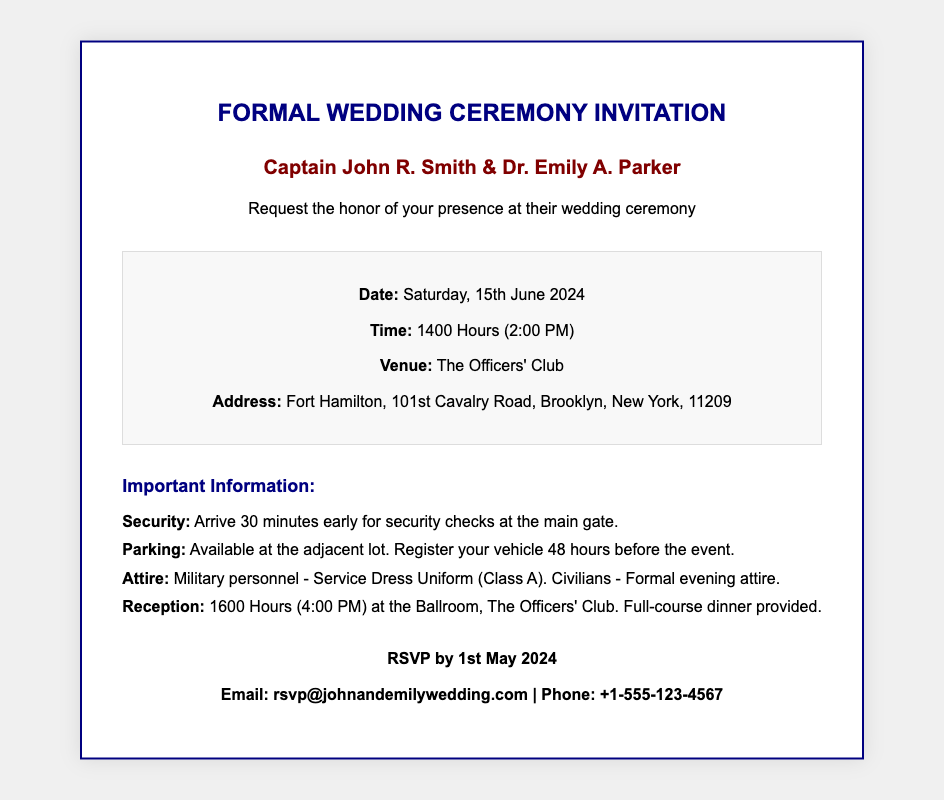what is the date of the wedding ceremony? The document specifies the date of the wedding ceremony, which is clearly stated.
Answer: Saturday, 15th June 2024 what time does the ceremony start? The starting time for the wedding ceremony is explicitly mentioned in the document.
Answer: 1400 Hours (2:00 PM) where is the wedding ceremony taking place? The venue for the wedding ceremony is clearly indicated in the document.
Answer: The Officers' Club what is the address of the venue? The document provides the full address where the ceremony will be held.
Answer: Fort Hamilton, 101st Cavalry Road, Brooklyn, New York, 11209 what attire should military personnel wear? The required attire for military personnel is specifically stated in the logistics section.
Answer: Service Dress Uniform (Class A) how early should guests arrive for security checks? The document outlines the timing for guests to arrive for necessary security procedures.
Answer: 30 minutes early when is the reception scheduled to start? The start time for the reception is provided in the document.
Answer: 1600 Hours (4:00 PM) what should civilians wear to the ceremony? The attire for civilian guests is described in the logistics section.
Answer: Formal evening attire when is the RSVP deadline? The deadline for RSVPs is stated clearly in the document.
Answer: 1st May 2024 